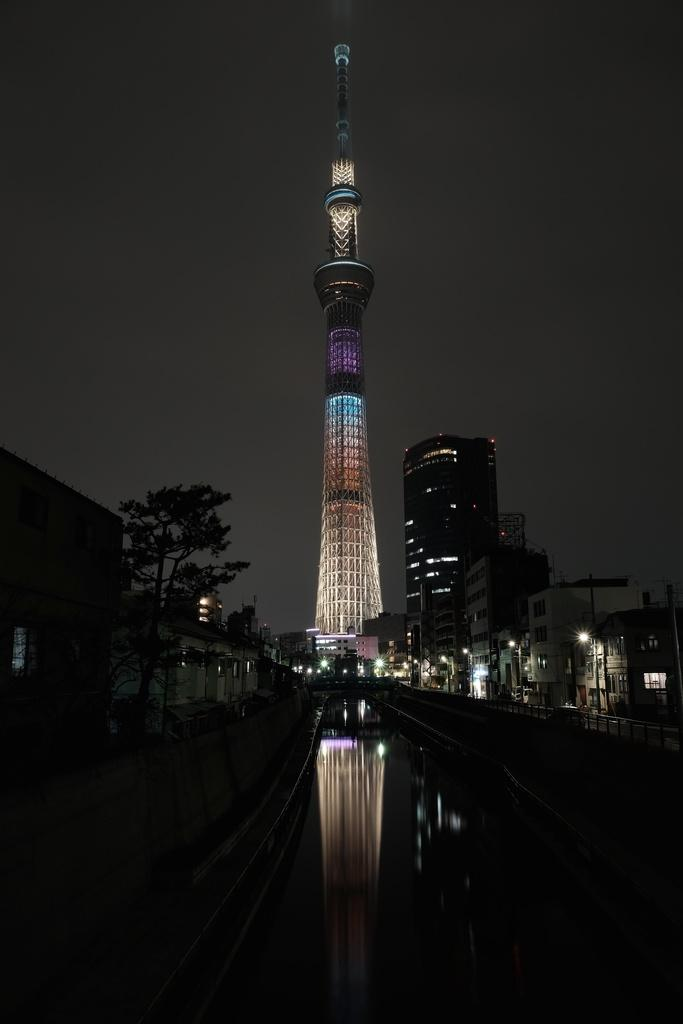What is the main structure in the image? There is a tower in the image. What type of buildings can be seen in the image? There are buildings with windows in the image. What can be seen illuminated in the image? There are lights visible in the image. What type of vegetation is present in the image? There are trees in the image. What is visible in the background of the image? The sky is visible in the background of the image. Where is the playground located in the image? There is no playground present in the image. What type of brass instrument is being played in the image? There is no brass instrument or any musical instrument being played in the image. 